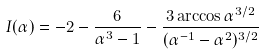Convert formula to latex. <formula><loc_0><loc_0><loc_500><loc_500>I ( \alpha ) = - 2 - \frac { 6 } { \alpha ^ { 3 } - 1 } - \frac { 3 \arccos \alpha ^ { 3 / 2 } } { ( \alpha ^ { - 1 } - \alpha ^ { 2 } ) ^ { 3 / 2 } }</formula> 